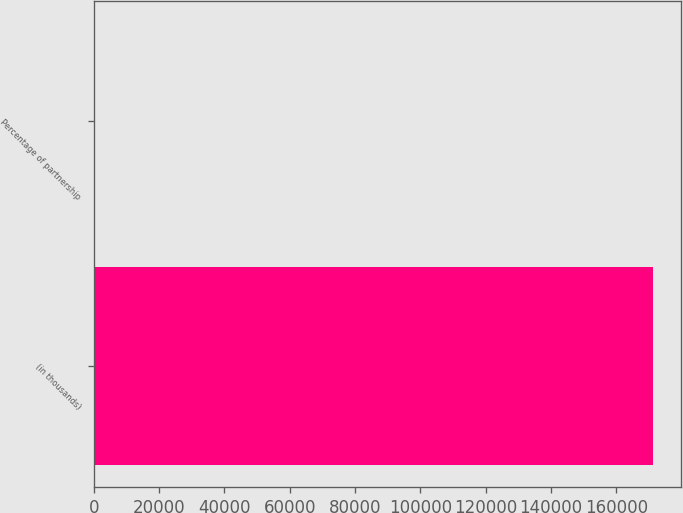Convert chart to OTSL. <chart><loc_0><loc_0><loc_500><loc_500><bar_chart><fcel>(in thousands)<fcel>Percentage of partnership<nl><fcel>171365<fcel>99.8<nl></chart> 